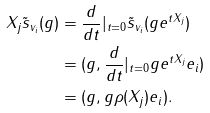Convert formula to latex. <formula><loc_0><loc_0><loc_500><loc_500>X _ { j } \tilde { s } _ { v _ { i } } ( g ) & = \frac { d } { d t } | _ { t = 0 } \tilde { s } _ { v _ { i } } ( g e ^ { t X _ { j } } ) \\ & = ( g , \frac { d } { d t } | _ { t = 0 } g e ^ { t X _ { j } } e _ { i } ) \\ & = ( g , g \rho ( X _ { j } ) e _ { i } ) .</formula> 